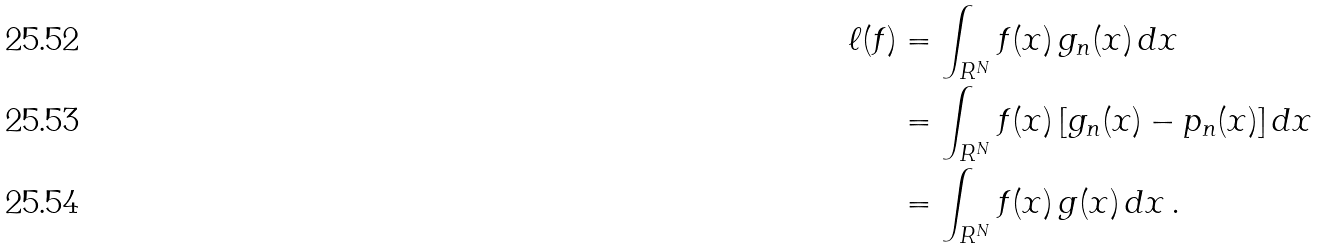Convert formula to latex. <formula><loc_0><loc_0><loc_500><loc_500>\ell ( f ) & = \int _ { R ^ { N } } f ( x ) \, g _ { n } ( x ) \, d x \\ & = \int _ { R ^ { N } } f ( x ) \, [ g _ { n } ( x ) - p _ { n } ( x ) ] \, d x \\ & = \int _ { R ^ { N } } f ( x ) \, g ( x ) \, d x \, .</formula> 